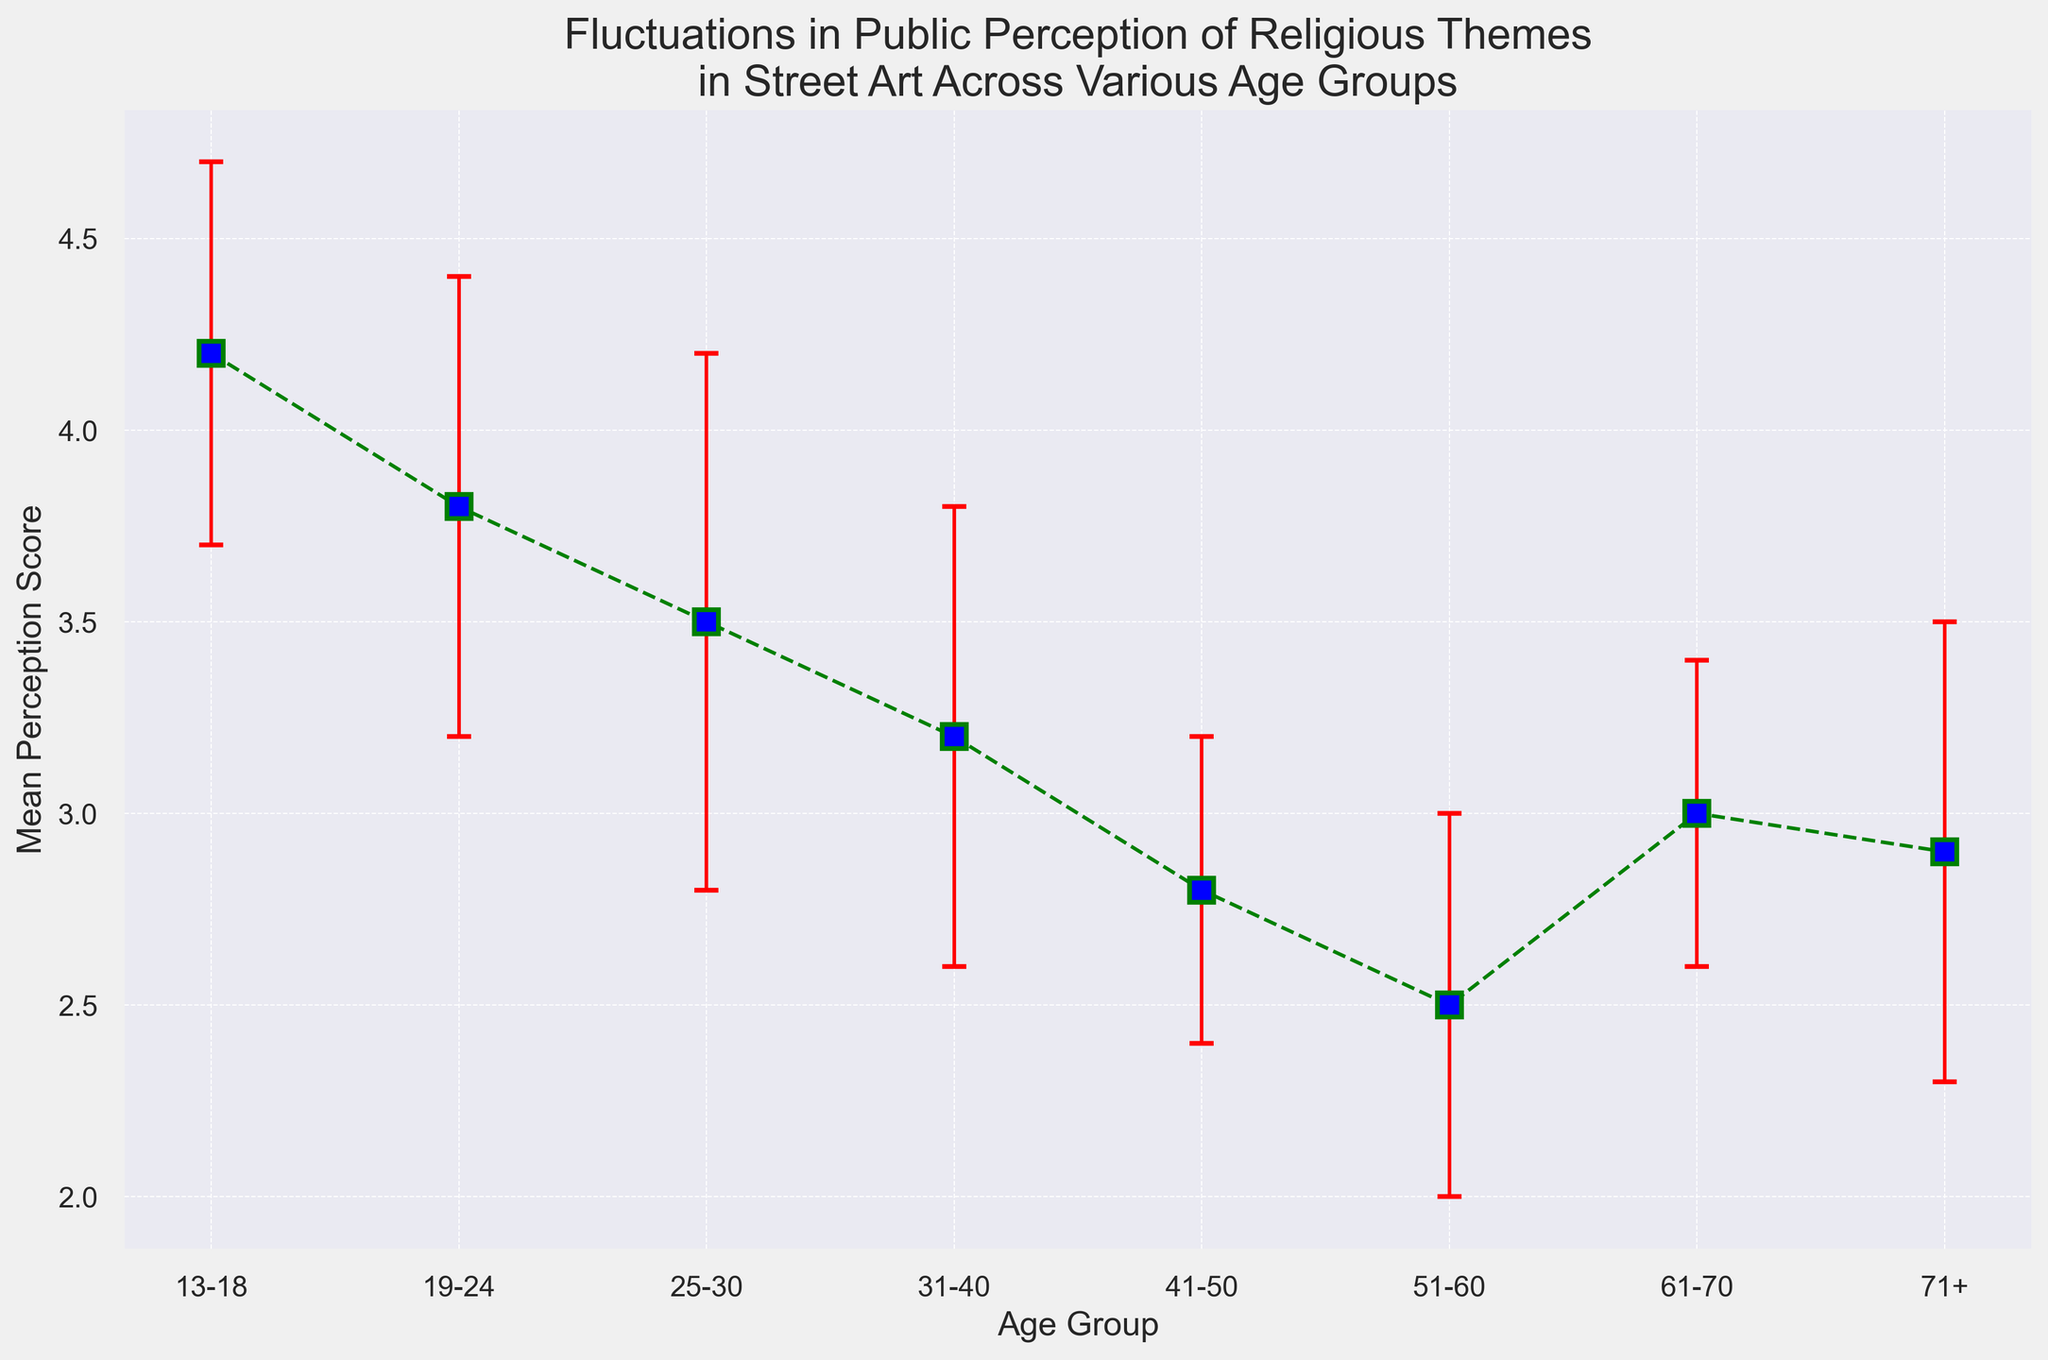Which age group has the highest mean perception score? Based on the figure, the age group "13-18" has the highest mean perception score with a value of 4.2.
Answer: 13-18 Which age group has the lowest mean perception score? According to the figure, the age group "51-60" has the lowest mean perception score, which is 2.5.
Answer: 51-60 What is the difference in the mean perception score between the age groups 13-18 and 31-40? The mean perception score for the age group "13-18" is 4.2, and for "31-40," it is 3.2. The difference between them is 4.2 - 3.2 = 1.0.
Answer: 1.0 Which age groups have a mean perception score greater than 3.0? Based on the figure, the age groups "13-18" (4.2), "19-24" (3.8), "25-30" (3.5), and "61-70" (3.0) have mean perception scores greater than 3.0.
Answer: 13-18, 19-24, 25-30, 61-70 Which age group shows the largest margin of error in the mean perception score? The margin of error is represented by the error bars on the plot. The age group "25-30" has the largest error bar with a standard deviation of 0.7.
Answer: 25-30 By how much does the mean perception score change from the age group 41-50 to the age group 51-60? The mean perception score for the age group "41-50" is 2.8, and for "51-60," it is 2.5. The change is 2.8 - 2.5 = 0.3.
Answer: 0.3 How many age groups have a lower mean perception score than "31-40"? The mean perception score for the age group "31-40" is 3.2. The age groups with lower mean perception scores are "41-50" (2.8), "51-60" (2.5), and "71+" (2.9). This totals to 3 age groups.
Answer: 3 Which age group shows an increasing trend after age group 51-60? The trend shows that after the age group "51-60" (2.5), the mean perception score increases for "61-70" (3.0) and "71+" (2.9).
Answer: 61-70 What is the average mean perception score across all age groups? To find the average, sum the mean perception scores (4.2 + 3.8 + 3.5 + 3.2 + 2.8 + 2.5 + 3.0 + 2.9) = 25.9, and divide by the number of age groups (8). The average is 25.9 / 8 = 3.2375.
Answer: 3.24 